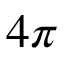<formula> <loc_0><loc_0><loc_500><loc_500>4 \pi</formula> 